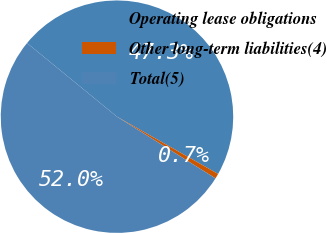<chart> <loc_0><loc_0><loc_500><loc_500><pie_chart><fcel>Operating lease obligations<fcel>Other long-term liabilities(4)<fcel>Total(5)<nl><fcel>47.28%<fcel>0.71%<fcel>52.01%<nl></chart> 